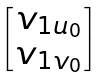<formula> <loc_0><loc_0><loc_500><loc_500>\begin{bmatrix} v _ { 1 u _ { 0 } } \\ v _ { 1 v _ { 0 } } \end{bmatrix}</formula> 